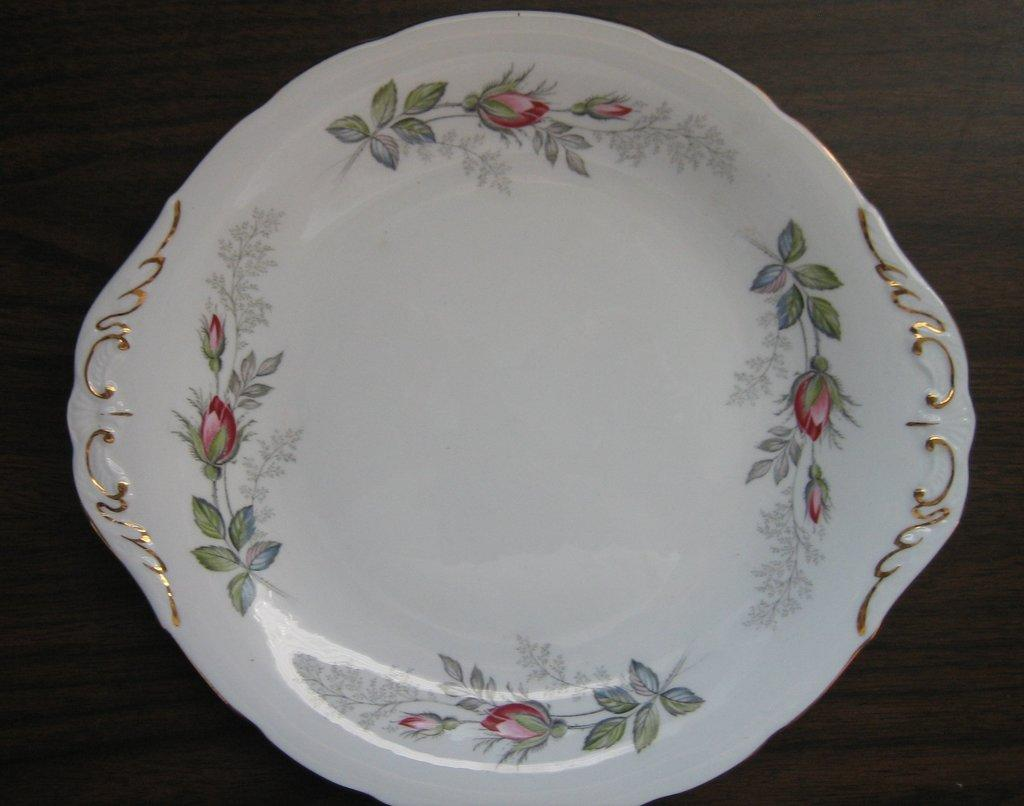What color is the plate that is visible in the image? The plate in the image is white. Where is the white plate located in the image? The white plate is on a wooden surface. How many fangs can be seen on the plate in the image? There are no fangs present on the plate in the image. What town is depicted in the background of the image? There is no town visible in the image; it only features a white plate on a wooden surface. 